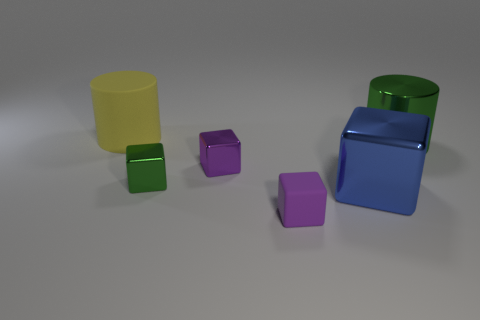Does the rubber object in front of the big green metallic cylinder have the same color as the large cube?
Make the answer very short. No. Are there any large things in front of the big blue metallic cube in front of the large cylinder that is in front of the yellow cylinder?
Your response must be concise. No. There is a thing that is both to the left of the small purple metallic block and in front of the yellow object; what shape is it?
Your answer should be compact. Cube. Are there any other metallic blocks of the same color as the large metal block?
Give a very brief answer. No. There is a rubber cylinder behind the tiny cube in front of the big blue thing; what is its color?
Make the answer very short. Yellow. There is a green thing that is right of the green metallic thing in front of the big cylinder in front of the large matte cylinder; what size is it?
Your answer should be compact. Large. Is the material of the tiny green object the same as the tiny purple object in front of the tiny purple metal object?
Provide a short and direct response. No. What size is the green cylinder that is made of the same material as the blue block?
Keep it short and to the point. Large. Are there any tiny blue objects that have the same shape as the big yellow rubber thing?
Your answer should be very brief. No. What number of objects are either matte objects that are on the right side of the yellow thing or gray matte cylinders?
Provide a short and direct response. 1. 